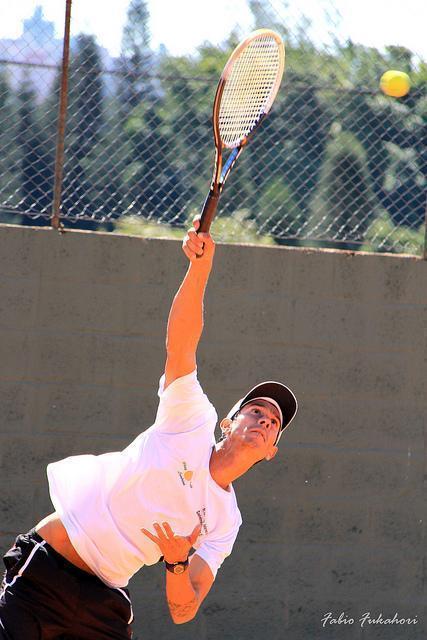What is his wrist accessory used for?
Pick the correct solution from the four options below to address the question.
Options: Administer insulin, measure speed, tell time, wipe sweat. Tell time. 